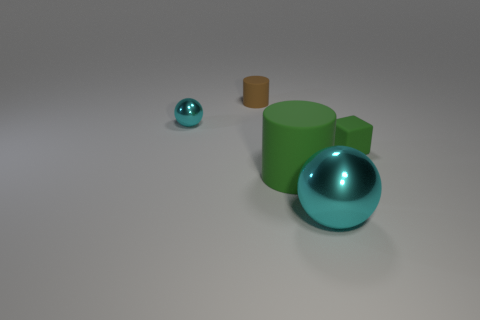Is there anything else that is the same shape as the tiny green object?
Your response must be concise. No. Is the color of the small ball the same as the large sphere?
Ensure brevity in your answer.  Yes. There is a small thing that is on the right side of the small matte thing behind the tiny cyan shiny sphere; what color is it?
Provide a short and direct response. Green. There is a cylinder that is the same color as the small matte cube; what is its size?
Give a very brief answer. Large. There is a cyan thing that is behind the cyan thing that is on the right side of the tiny shiny object; what number of shiny balls are on the right side of it?
Offer a terse response. 1. Do the metallic thing that is behind the small green rubber block and the large object to the right of the big green object have the same shape?
Keep it short and to the point. Yes. What number of objects are small rubber things or big metallic objects?
Offer a terse response. 3. What is the material of the sphere behind the metal thing on the right side of the small metallic thing?
Keep it short and to the point. Metal. Is there another metallic ball that has the same color as the large ball?
Provide a short and direct response. Yes. There is a cylinder that is the same size as the block; what is its color?
Your answer should be compact. Brown. 